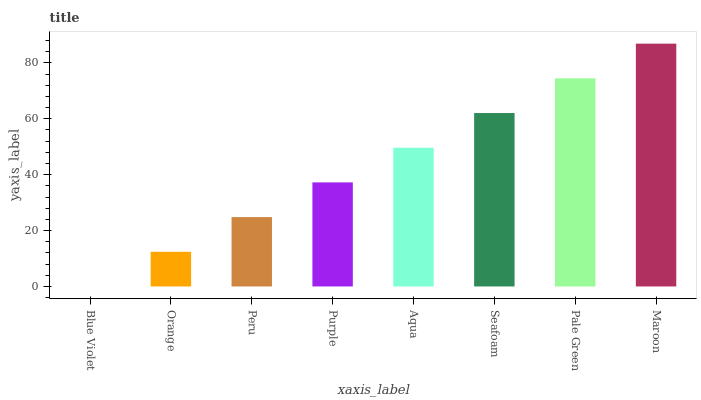Is Blue Violet the minimum?
Answer yes or no. Yes. Is Maroon the maximum?
Answer yes or no. Yes. Is Orange the minimum?
Answer yes or no. No. Is Orange the maximum?
Answer yes or no. No. Is Orange greater than Blue Violet?
Answer yes or no. Yes. Is Blue Violet less than Orange?
Answer yes or no. Yes. Is Blue Violet greater than Orange?
Answer yes or no. No. Is Orange less than Blue Violet?
Answer yes or no. No. Is Aqua the high median?
Answer yes or no. Yes. Is Purple the low median?
Answer yes or no. Yes. Is Seafoam the high median?
Answer yes or no. No. Is Aqua the low median?
Answer yes or no. No. 